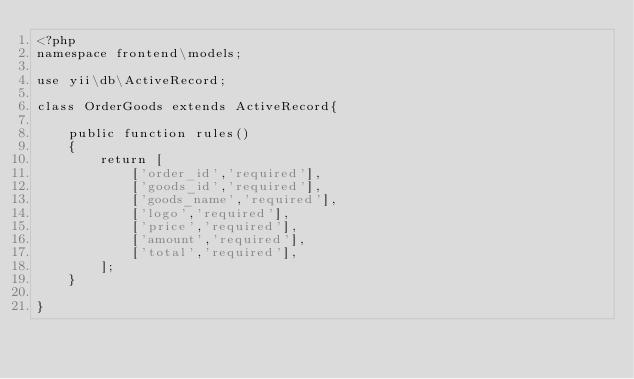Convert code to text. <code><loc_0><loc_0><loc_500><loc_500><_PHP_><?php
namespace frontend\models;

use yii\db\ActiveRecord;

class OrderGoods extends ActiveRecord{

    public function rules()
    {
        return [
            ['order_id','required'],
            ['goods_id','required'],
            ['goods_name','required'],
            ['logo','required'],
            ['price','required'],
            ['amount','required'],
            ['total','required'],
        ];
    }

}</code> 